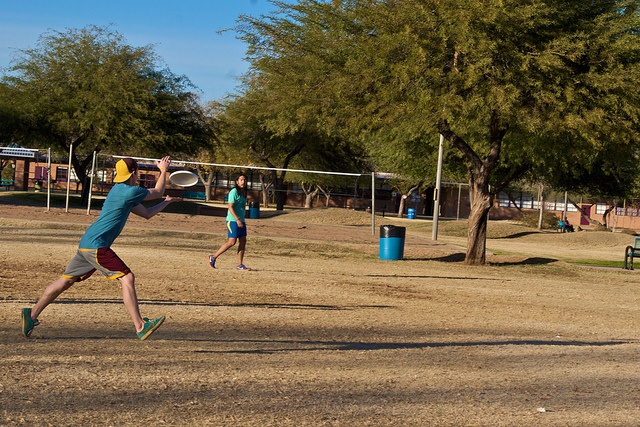Describe the objects in this image and their specific colors. I can see people in lightblue, black, maroon, gray, and tan tones, people in lightblue, black, tan, gray, and darkblue tones, frisbee in lightblue, gray, and white tones, bench in lightblue, black, darkgreen, and gray tones, and people in lightblue, black, maroon, brown, and gray tones in this image. 